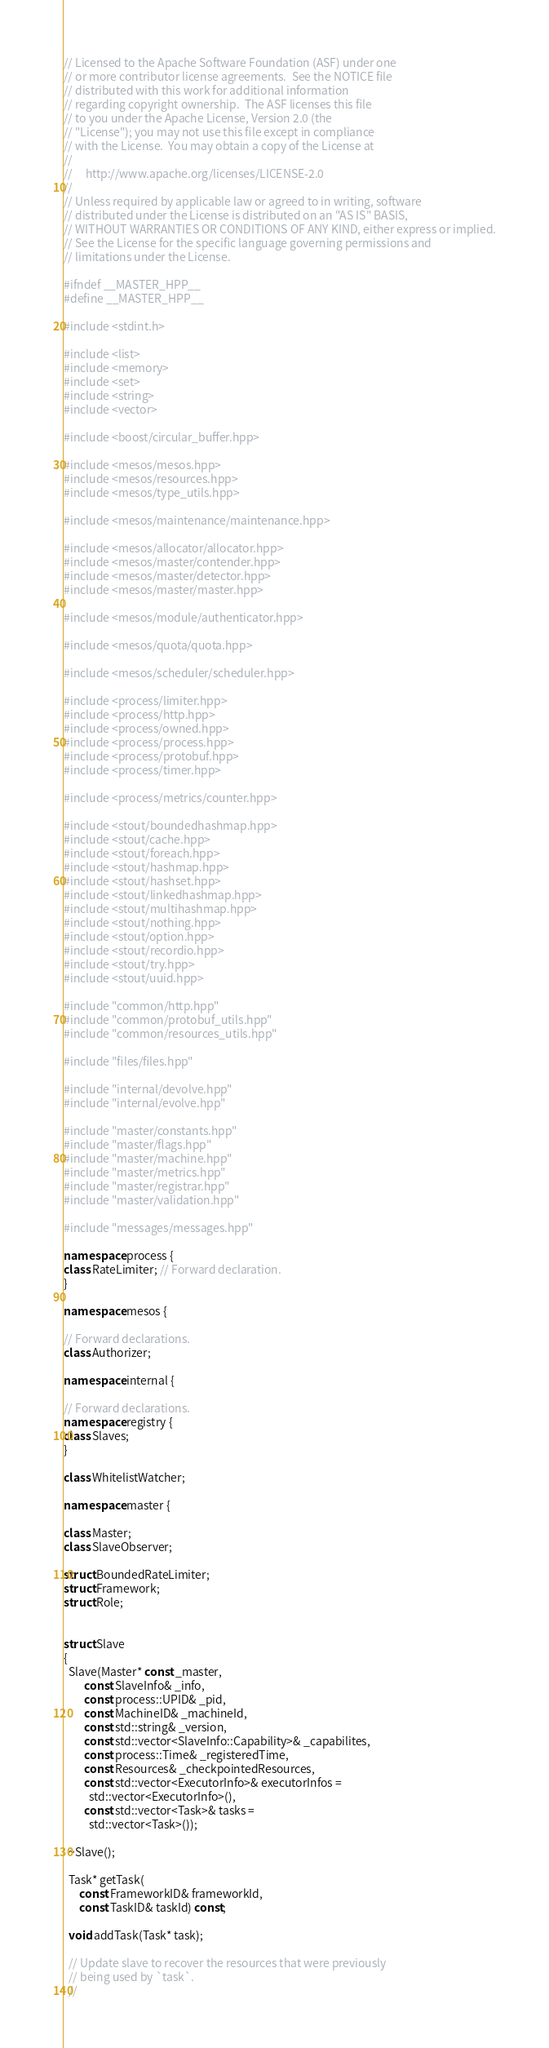<code> <loc_0><loc_0><loc_500><loc_500><_C++_>// Licensed to the Apache Software Foundation (ASF) under one
// or more contributor license agreements.  See the NOTICE file
// distributed with this work for additional information
// regarding copyright ownership.  The ASF licenses this file
// to you under the Apache License, Version 2.0 (the
// "License"); you may not use this file except in compliance
// with the License.  You may obtain a copy of the License at
//
//     http://www.apache.org/licenses/LICENSE-2.0
//
// Unless required by applicable law or agreed to in writing, software
// distributed under the License is distributed on an "AS IS" BASIS,
// WITHOUT WARRANTIES OR CONDITIONS OF ANY KIND, either express or implied.
// See the License for the specific language governing permissions and
// limitations under the License.

#ifndef __MASTER_HPP__
#define __MASTER_HPP__

#include <stdint.h>

#include <list>
#include <memory>
#include <set>
#include <string>
#include <vector>

#include <boost/circular_buffer.hpp>

#include <mesos/mesos.hpp>
#include <mesos/resources.hpp>
#include <mesos/type_utils.hpp>

#include <mesos/maintenance/maintenance.hpp>

#include <mesos/allocator/allocator.hpp>
#include <mesos/master/contender.hpp>
#include <mesos/master/detector.hpp>
#include <mesos/master/master.hpp>

#include <mesos/module/authenticator.hpp>

#include <mesos/quota/quota.hpp>

#include <mesos/scheduler/scheduler.hpp>

#include <process/limiter.hpp>
#include <process/http.hpp>
#include <process/owned.hpp>
#include <process/process.hpp>
#include <process/protobuf.hpp>
#include <process/timer.hpp>

#include <process/metrics/counter.hpp>

#include <stout/boundedhashmap.hpp>
#include <stout/cache.hpp>
#include <stout/foreach.hpp>
#include <stout/hashmap.hpp>
#include <stout/hashset.hpp>
#include <stout/linkedhashmap.hpp>
#include <stout/multihashmap.hpp>
#include <stout/nothing.hpp>
#include <stout/option.hpp>
#include <stout/recordio.hpp>
#include <stout/try.hpp>
#include <stout/uuid.hpp>

#include "common/http.hpp"
#include "common/protobuf_utils.hpp"
#include "common/resources_utils.hpp"

#include "files/files.hpp"

#include "internal/devolve.hpp"
#include "internal/evolve.hpp"

#include "master/constants.hpp"
#include "master/flags.hpp"
#include "master/machine.hpp"
#include "master/metrics.hpp"
#include "master/registrar.hpp"
#include "master/validation.hpp"

#include "messages/messages.hpp"

namespace process {
class RateLimiter; // Forward declaration.
}

namespace mesos {

// Forward declarations.
class Authorizer;

namespace internal {

// Forward declarations.
namespace registry {
class Slaves;
}

class WhitelistWatcher;

namespace master {

class Master;
class SlaveObserver;

struct BoundedRateLimiter;
struct Framework;
struct Role;


struct Slave
{
  Slave(Master* const _master,
        const SlaveInfo& _info,
        const process::UPID& _pid,
        const MachineID& _machineId,
        const std::string& _version,
        const std::vector<SlaveInfo::Capability>& _capabilites,
        const process::Time& _registeredTime,
        const Resources& _checkpointedResources,
        const std::vector<ExecutorInfo>& executorInfos =
          std::vector<ExecutorInfo>(),
        const std::vector<Task>& tasks =
          std::vector<Task>());

  ~Slave();

  Task* getTask(
      const FrameworkID& frameworkId,
      const TaskID& taskId) const;

  void addTask(Task* task);

  // Update slave to recover the resources that were previously
  // being used by `task`.
  //</code> 